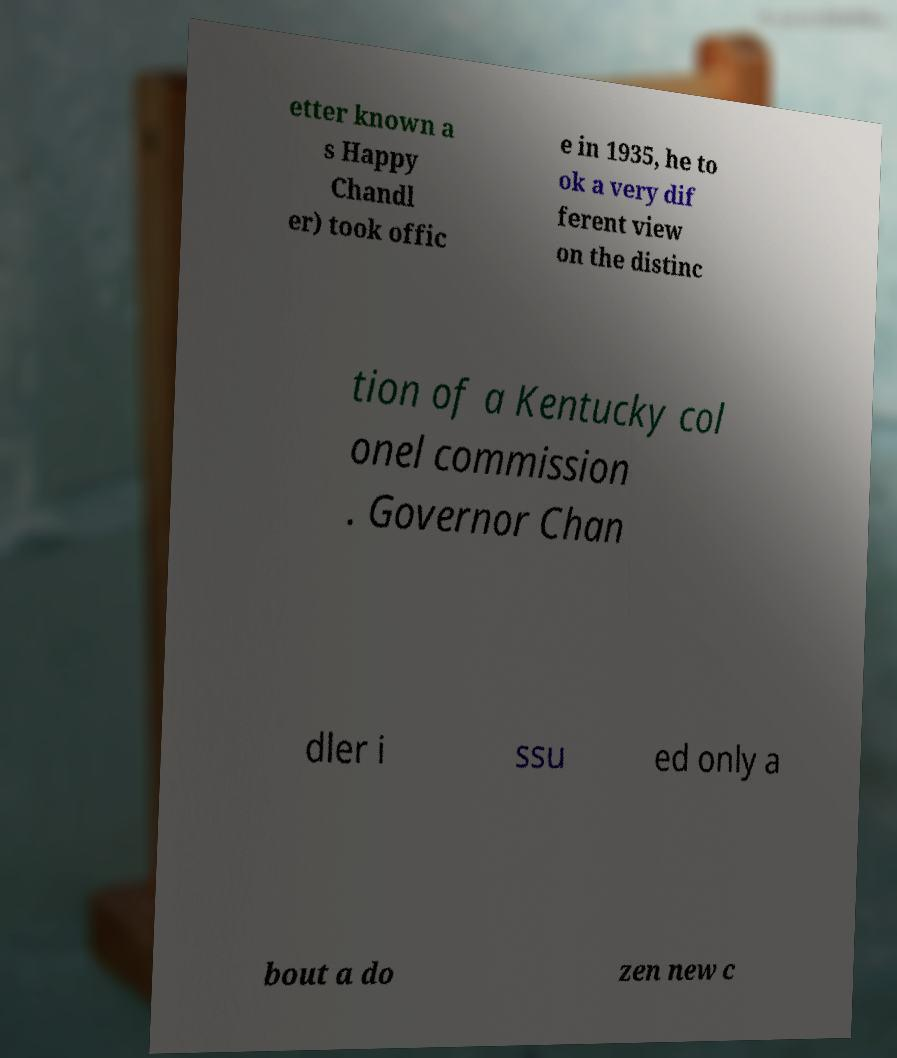Could you extract and type out the text from this image? etter known a s Happy Chandl er) took offic e in 1935, he to ok a very dif ferent view on the distinc tion of a Kentucky col onel commission . Governor Chan dler i ssu ed only a bout a do zen new c 